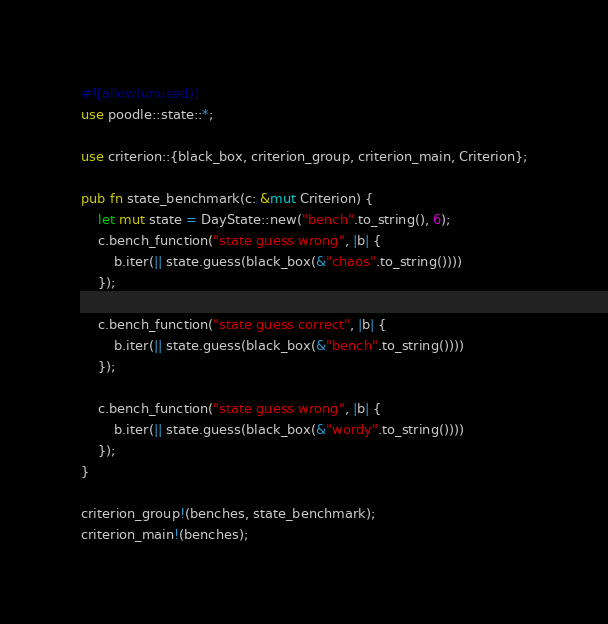<code> <loc_0><loc_0><loc_500><loc_500><_Rust_>#![allow(unused)]
use poodle::state::*;

use criterion::{black_box, criterion_group, criterion_main, Criterion};

pub fn state_benchmark(c: &mut Criterion) {
    let mut state = DayState::new("bench".to_string(), 6);
    c.bench_function("state guess wrong", |b| {
        b.iter(|| state.guess(black_box(&"chaos".to_string())))
    });

    c.bench_function("state guess correct", |b| {
        b.iter(|| state.guess(black_box(&"bench".to_string())))
    });

    c.bench_function("state guess wrong", |b| {
        b.iter(|| state.guess(black_box(&"wordy".to_string())))
    });
}

criterion_group!(benches, state_benchmark);
criterion_main!(benches);
</code> 